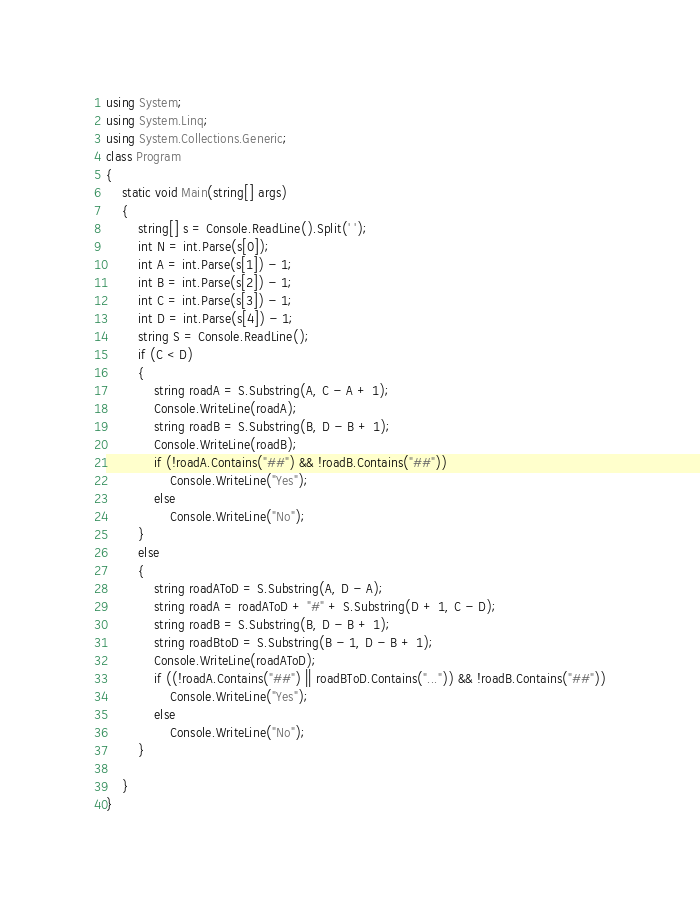<code> <loc_0><loc_0><loc_500><loc_500><_C#_>using System;
using System.Linq;
using System.Collections.Generic;
class Program
{
    static void Main(string[] args)
    {
        string[] s = Console.ReadLine().Split(' ');
        int N = int.Parse(s[0]);
        int A = int.Parse(s[1]) - 1;
        int B = int.Parse(s[2]) - 1;
        int C = int.Parse(s[3]) - 1;
        int D = int.Parse(s[4]) - 1;
        string S = Console.ReadLine();
        if (C < D)
        {
            string roadA = S.Substring(A, C - A + 1);
            Console.WriteLine(roadA);
            string roadB = S.Substring(B, D - B + 1);
            Console.WriteLine(roadB);
            if (!roadA.Contains("##") && !roadB.Contains("##"))
                Console.WriteLine("Yes");
            else
                Console.WriteLine("No");
        }
        else
        {
            string roadAToD = S.Substring(A, D - A);
            string roadA = roadAToD + "#" + S.Substring(D + 1, C - D);
            string roadB = S.Substring(B, D - B + 1);
            string roadBtoD = S.Substring(B - 1, D - B + 1);
            Console.WriteLine(roadAToD);
            if ((!roadA.Contains("##") || roadBToD.Contains("...")) && !roadB.Contains("##"))
                Console.WriteLine("Yes");
            else
                Console.WriteLine("No");
        }

    }
}</code> 